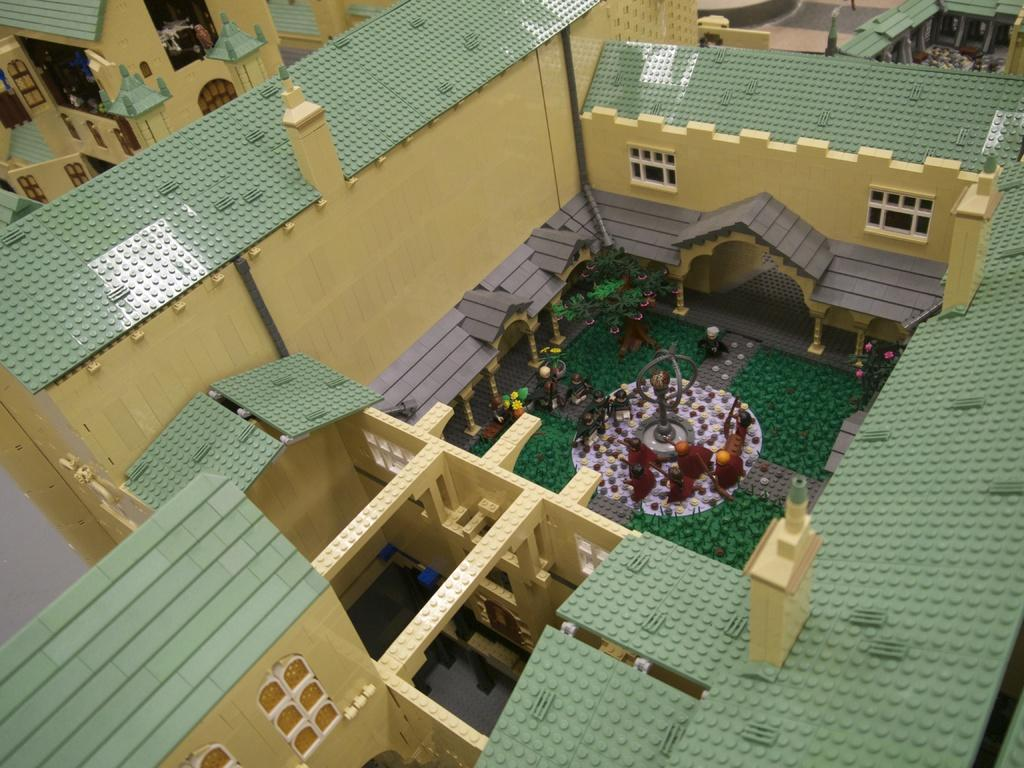What type of structure is visible in the image? There is a building in the image. What material is the building made of? The building is made up of blocks. Can you see a cat climbing the building in the image? There is no cat present in the image, and therefore no such activity can be observed. 